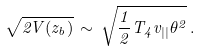Convert formula to latex. <formula><loc_0><loc_0><loc_500><loc_500>\sqrt { 2 V ( z _ { b } ) } \, \sim \, \sqrt { \frac { 1 } { 2 } T _ { 4 } v _ { | | } \theta ^ { 2 } } \, .</formula> 